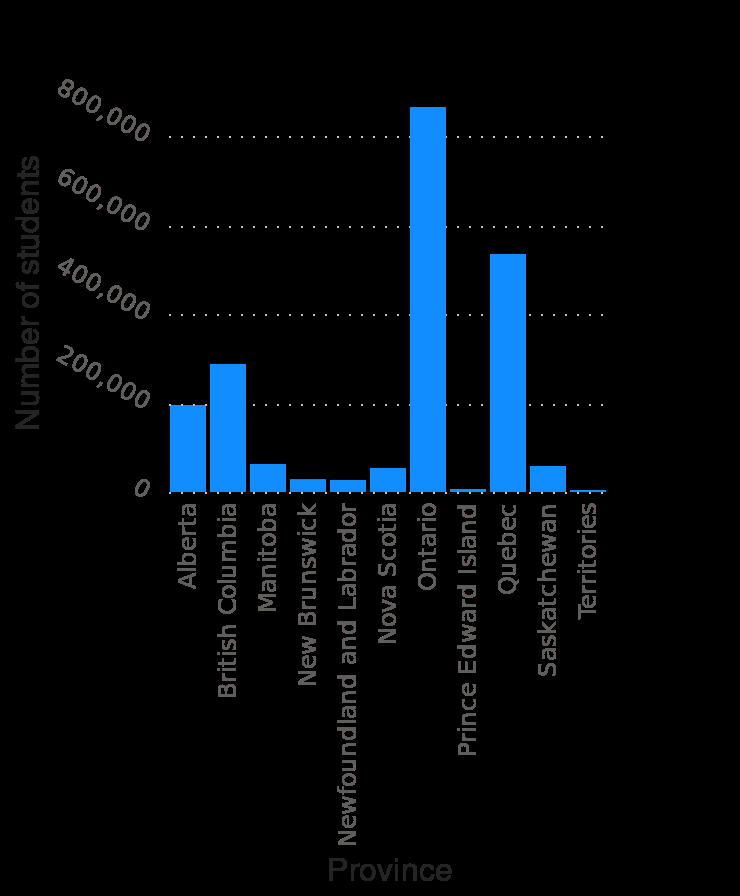<image>
Which province had the highest number of students enrolled in postsecondary institutions in Canada in 2017/18?  Ontario had the highest number of students enrolled in postsecondary institutions in Canada in 2017/18. What time period does the bar plot cover? The bar plot covers the academic year 2017/18. 